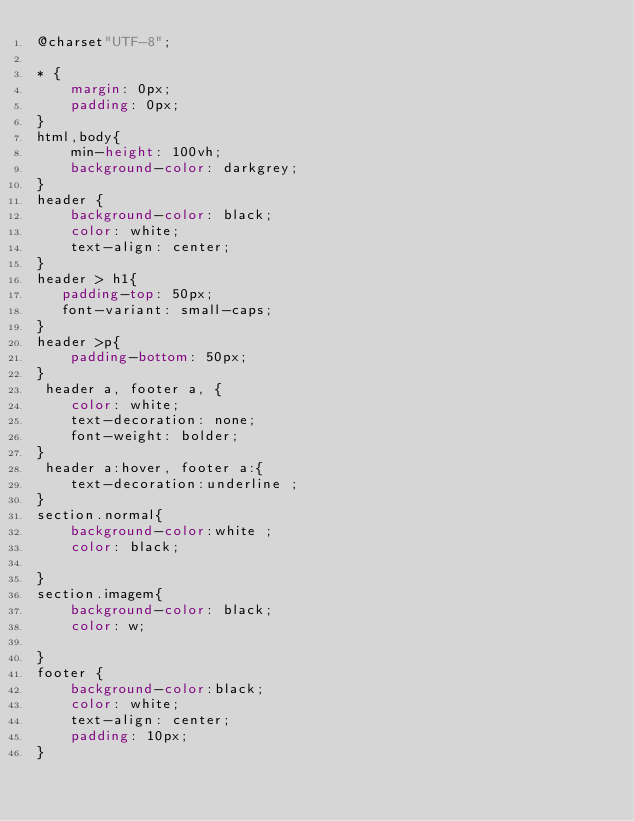Convert code to text. <code><loc_0><loc_0><loc_500><loc_500><_CSS_>@charset"UTF-8";

* {
    margin: 0px;
    padding: 0px;
}
html,body{
    min-height: 100vh; 
    background-color: darkgrey;
}
header {
    background-color: black;
    color: white;
    text-align: center;
}
header > h1{
   padding-top: 50px; 
   font-variant: small-caps;
}
header >p{
    padding-bottom: 50px;
}
 header a, footer a, { 
    color: white;
    text-decoration: none;
    font-weight: bolder;
}
 header a:hover, footer a:{
    text-decoration:underline ;
}
section.normal{
    background-color:white ;
    color: black;

}
section.imagem{
    background-color: black;
    color: w;

}
footer {
    background-color:black;
    color: white;
    text-align: center;
    padding: 10px; 
}
</code> 